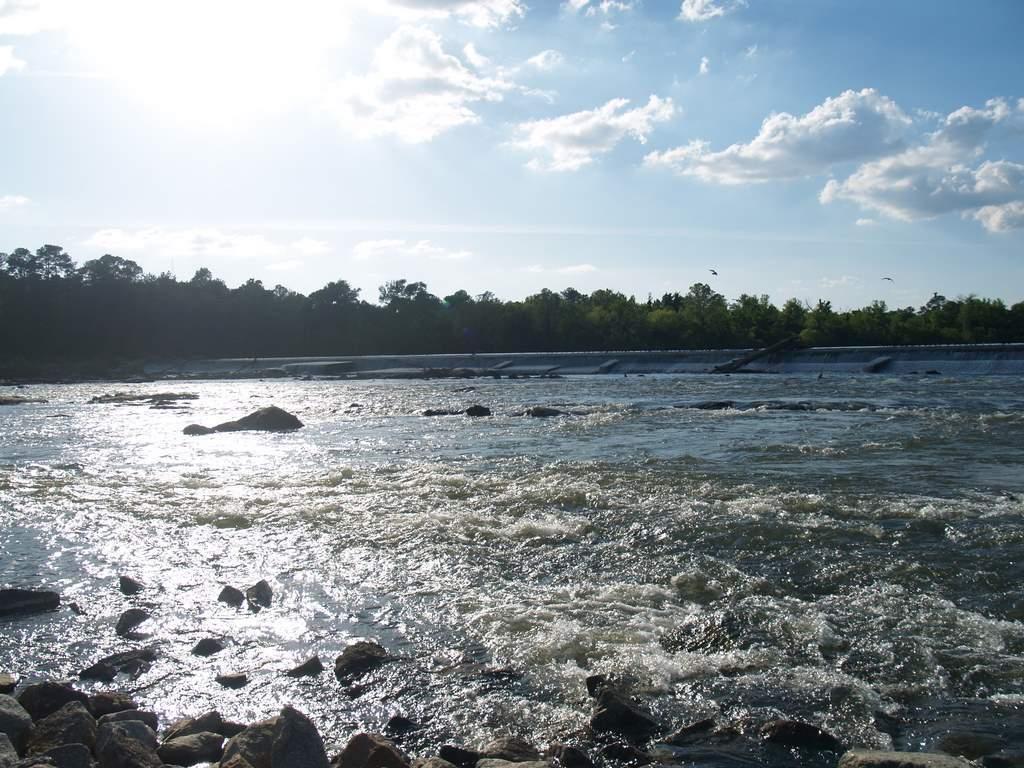In one or two sentences, can you explain what this image depicts? In this image we can see water. Also there are rocks. In the background there are trees and sky with clouds. 